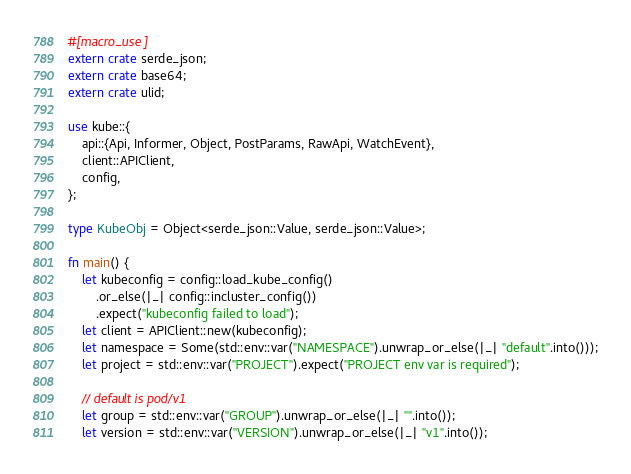<code> <loc_0><loc_0><loc_500><loc_500><_Rust_>#[macro_use]
extern crate serde_json;
extern crate base64;
extern crate ulid;

use kube::{
    api::{Api, Informer, Object, PostParams, RawApi, WatchEvent},
    client::APIClient,
    config,
};

type KubeObj = Object<serde_json::Value, serde_json::Value>;

fn main() {
    let kubeconfig = config::load_kube_config()
        .or_else(|_| config::incluster_config())
        .expect("kubeconfig failed to load");
    let client = APIClient::new(kubeconfig);
    let namespace = Some(std::env::var("NAMESPACE").unwrap_or_else(|_| "default".into()));
    let project = std::env::var("PROJECT").expect("PROJECT env var is required");

    // default is pod/v1
    let group = std::env::var("GROUP").unwrap_or_else(|_| "".into());
    let version = std::env::var("VERSION").unwrap_or_else(|_| "v1".into());</code> 